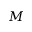<formula> <loc_0><loc_0><loc_500><loc_500>M</formula> 